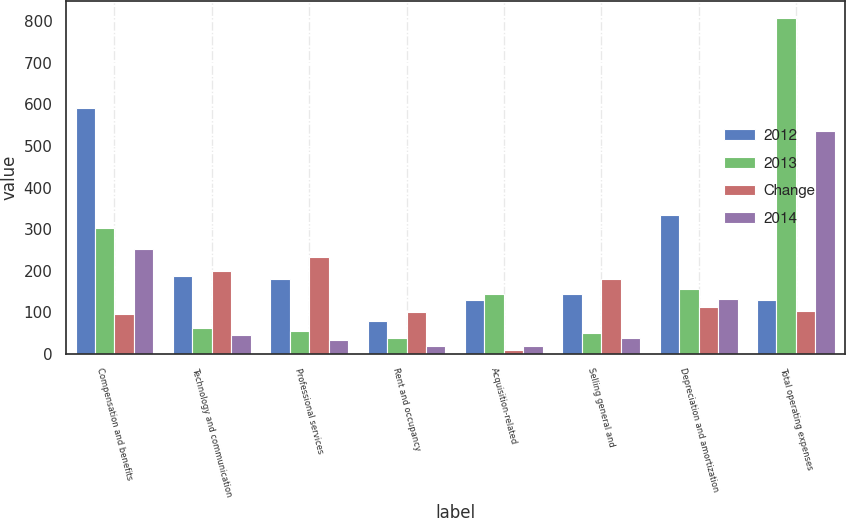<chart> <loc_0><loc_0><loc_500><loc_500><stacked_bar_chart><ecel><fcel>Compensation and benefits<fcel>Technology and communication<fcel>Professional services<fcel>Rent and occupancy<fcel>Acquisition-related<fcel>Selling general and<fcel>Depreciation and amortization<fcel>Total operating expenses<nl><fcel>2012<fcel>592<fcel>188<fcel>181<fcel>78<fcel>129<fcel>143<fcel>333<fcel>129<nl><fcel>2013<fcel>302<fcel>63<fcel>54<fcel>39<fcel>143<fcel>51<fcel>156<fcel>808<nl><fcel>Change<fcel>97<fcel>199<fcel>234<fcel>101<fcel>10<fcel>180<fcel>112<fcel>103<nl><fcel>2014<fcel>251<fcel>46<fcel>33<fcel>19<fcel>19<fcel>37<fcel>131<fcel>536<nl></chart> 